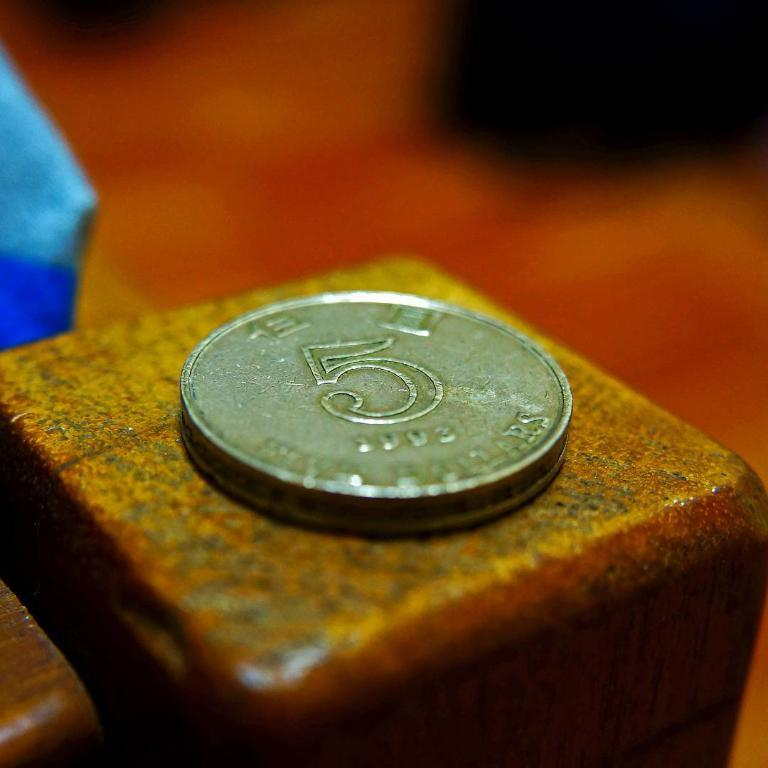<image>
Present a compact description of the photo's key features. A single coin from 1993 sits on a wood surface. 